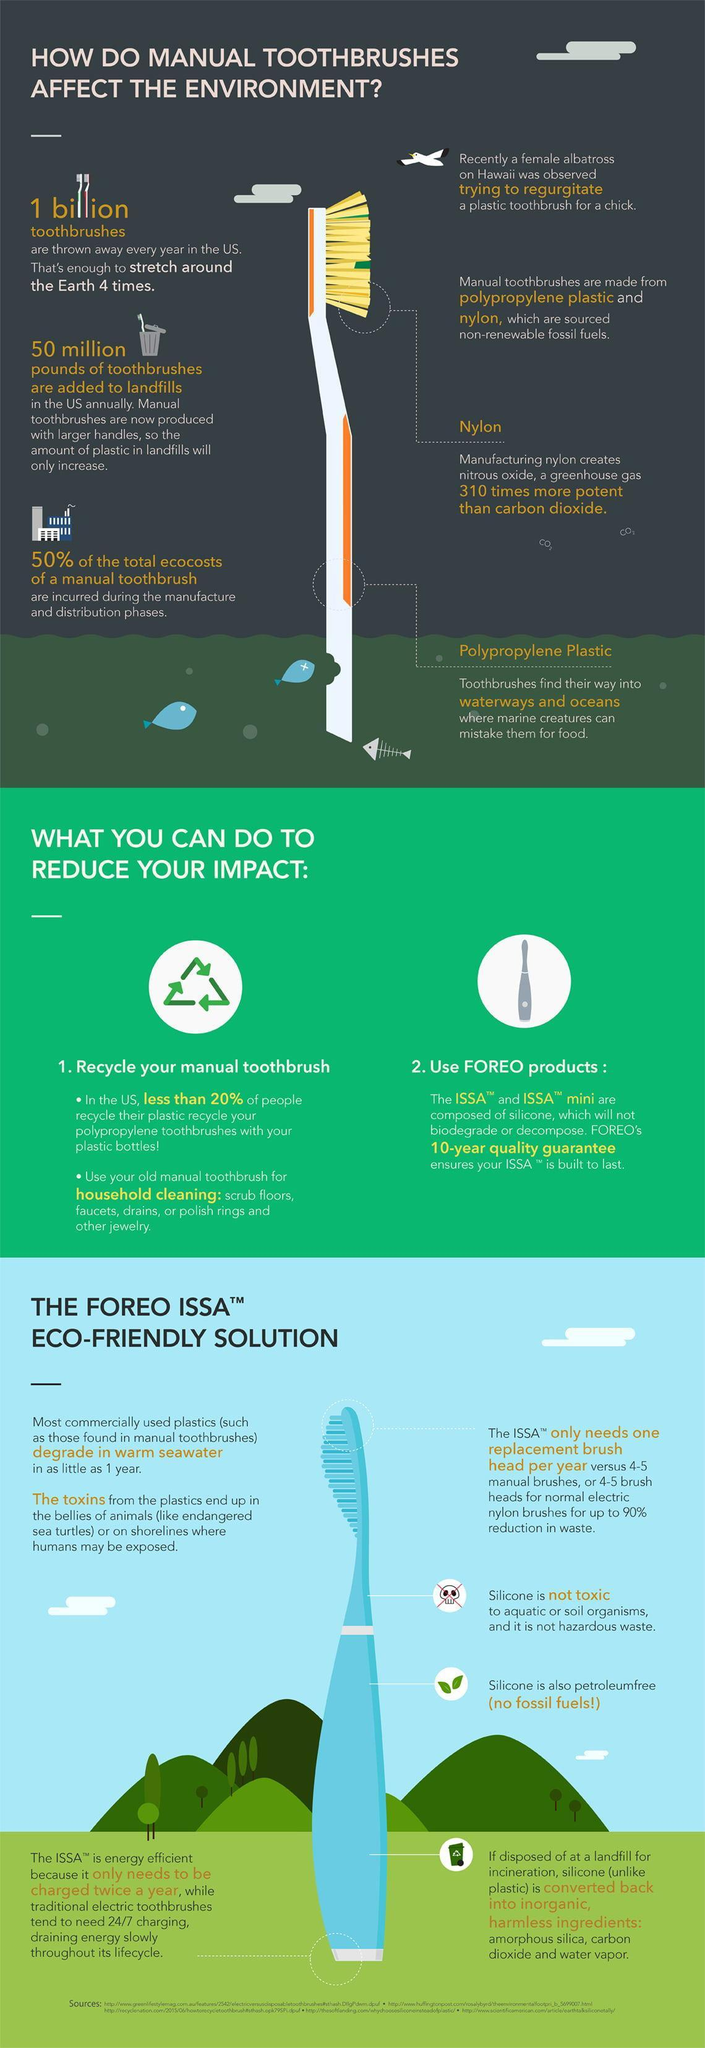What percent of US population recycle their toothbrushes?
Answer the question with a short phrase. less than 20% Which material is used to make the bristles of the manual toothbrush? Nylon Which material is used in the body of the manual toothbrush? Polypropylene plastic What degrades in warm sea water? most commercially used plastics On proper disposal which material gets converted into amorphous silica, carbon dioxide and water vapor? silicone Which product needs to be charged only twice a year? The ISSA How many toothbrushes are discarded each year in the US? 1 billion Which material is the main component in FOREO products? silicone 